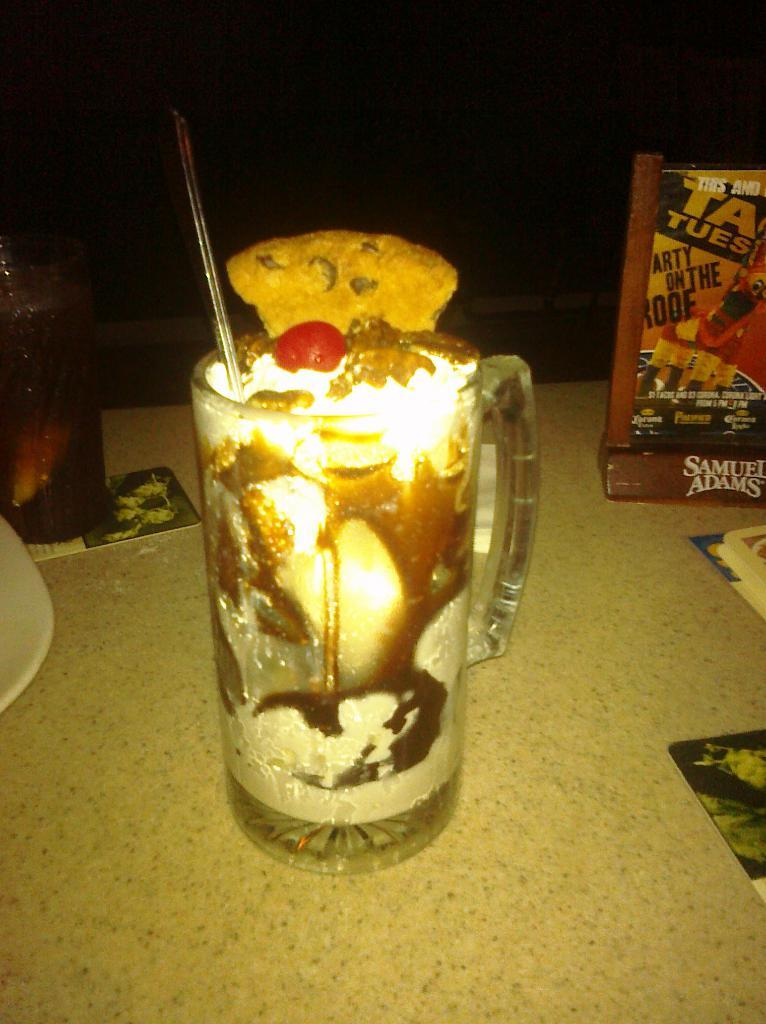<image>
Render a clear and concise summary of the photo. A fancy drink sits on a table near a Samuel Adams sign-holder. 